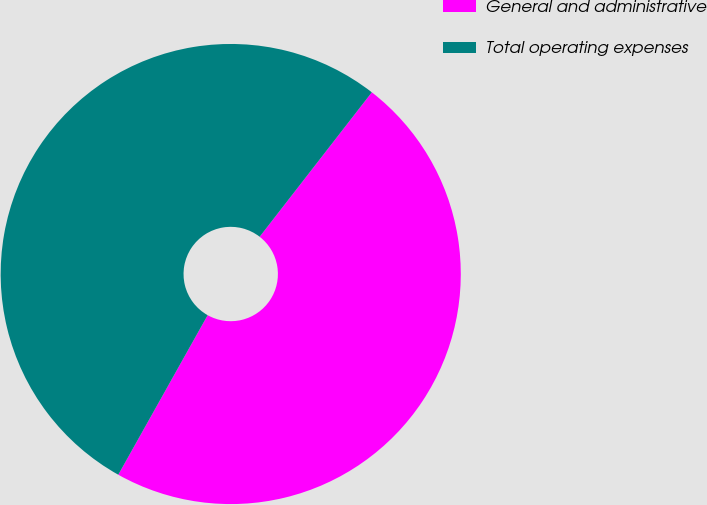Convert chart to OTSL. <chart><loc_0><loc_0><loc_500><loc_500><pie_chart><fcel>General and administrative<fcel>Total operating expenses<nl><fcel>47.62%<fcel>52.38%<nl></chart> 